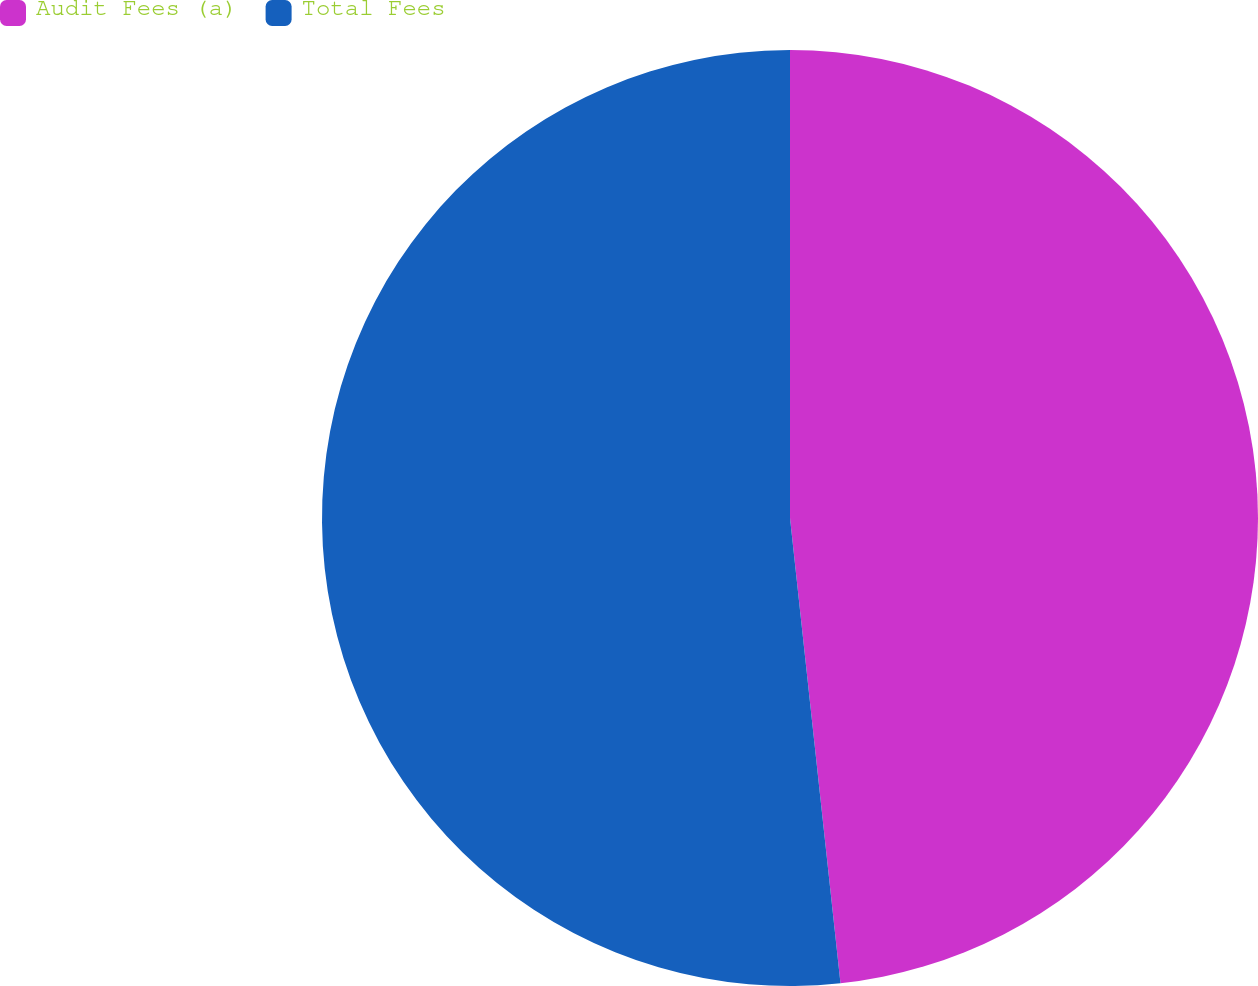<chart> <loc_0><loc_0><loc_500><loc_500><pie_chart><fcel>Audit Fees (a)<fcel>Total Fees<nl><fcel>48.28%<fcel>51.72%<nl></chart> 